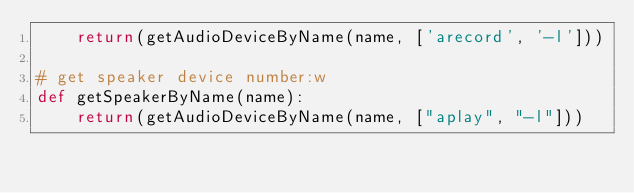<code> <loc_0><loc_0><loc_500><loc_500><_Python_>    return(getAudioDeviceByName(name, ['arecord', '-l']))
    
# get speaker device number:w
def getSpeakerByName(name):
    return(getAudioDeviceByName(name, ["aplay", "-l"]))

</code> 